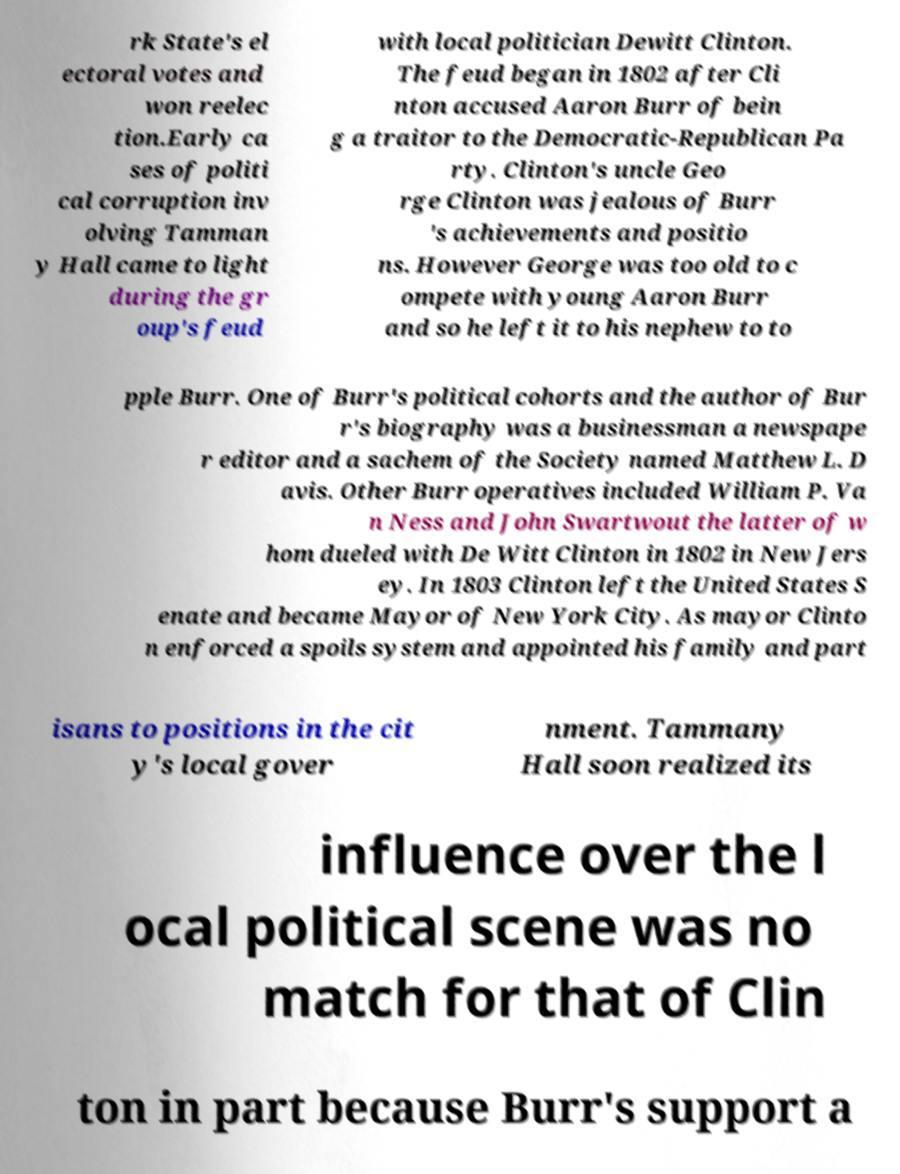There's text embedded in this image that I need extracted. Can you transcribe it verbatim? rk State's el ectoral votes and won reelec tion.Early ca ses of politi cal corruption inv olving Tamman y Hall came to light during the gr oup's feud with local politician Dewitt Clinton. The feud began in 1802 after Cli nton accused Aaron Burr of bein g a traitor to the Democratic-Republican Pa rty. Clinton's uncle Geo rge Clinton was jealous of Burr 's achievements and positio ns. However George was too old to c ompete with young Aaron Burr and so he left it to his nephew to to pple Burr. One of Burr's political cohorts and the author of Bur r's biography was a businessman a newspape r editor and a sachem of the Society named Matthew L. D avis. Other Burr operatives included William P. Va n Ness and John Swartwout the latter of w hom dueled with De Witt Clinton in 1802 in New Jers ey. In 1803 Clinton left the United States S enate and became Mayor of New York City. As mayor Clinto n enforced a spoils system and appointed his family and part isans to positions in the cit y's local gover nment. Tammany Hall soon realized its influence over the l ocal political scene was no match for that of Clin ton in part because Burr's support a 